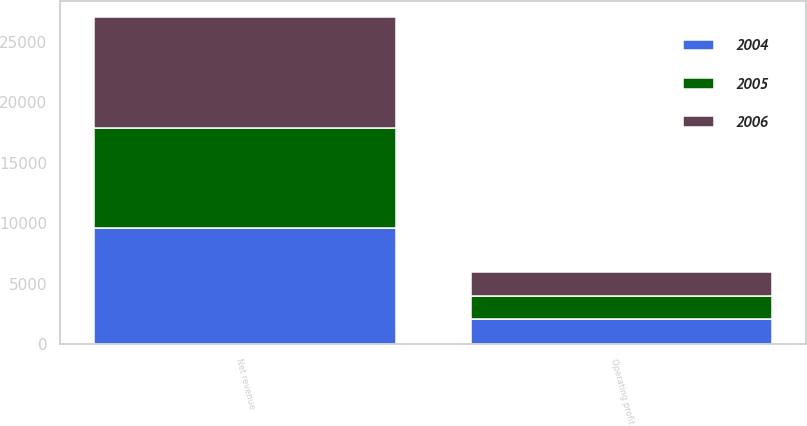<chart> <loc_0><loc_0><loc_500><loc_500><stacked_bar_chart><ecel><fcel>Net revenue<fcel>Operating profit<nl><fcel>2004<fcel>9565<fcel>2055<nl><fcel>2006<fcel>9146<fcel>2037<nl><fcel>2005<fcel>8313<fcel>1911<nl></chart> 